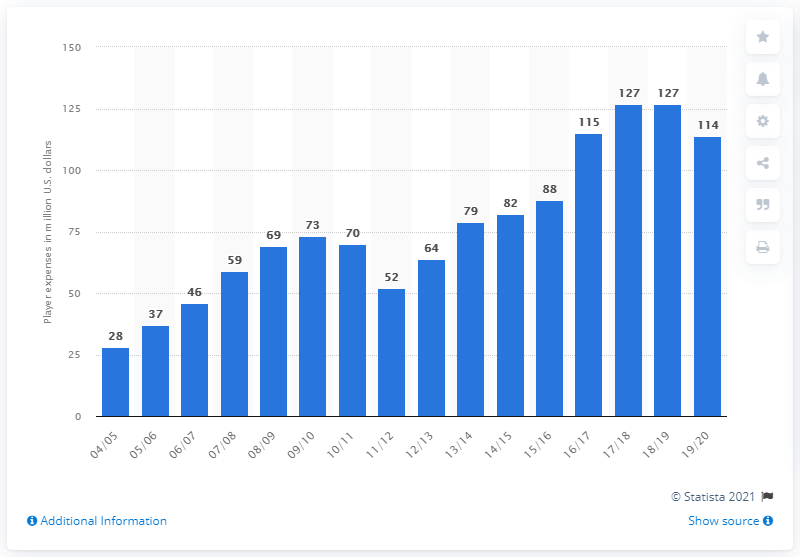Identify some key points in this picture. The player salaries of the Charlotte Hornets in the 2019/20 season were $114 million. 